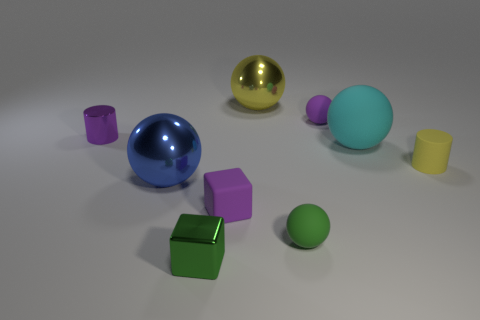What is the color of the tiny shiny object in front of the object on the left side of the metallic sphere that is on the left side of the purple cube?
Make the answer very short. Green. What number of other objects are the same shape as the purple metal object?
Give a very brief answer. 1. Does the small shiny block have the same color as the small shiny cylinder?
Provide a short and direct response. No. How many objects are either small matte blocks or tiny green things that are left of the tiny matte cube?
Ensure brevity in your answer.  2. Is there another red cylinder of the same size as the metallic cylinder?
Your answer should be compact. No. Is the material of the cyan ball the same as the purple cube?
Make the answer very short. Yes. How many things are shiny things or matte cylinders?
Your answer should be compact. 5. What is the size of the green rubber thing?
Keep it short and to the point. Small. Are there fewer small green metal cubes than large red objects?
Offer a terse response. No. What number of tiny rubber balls are the same color as the tiny matte cylinder?
Provide a short and direct response. 0. 